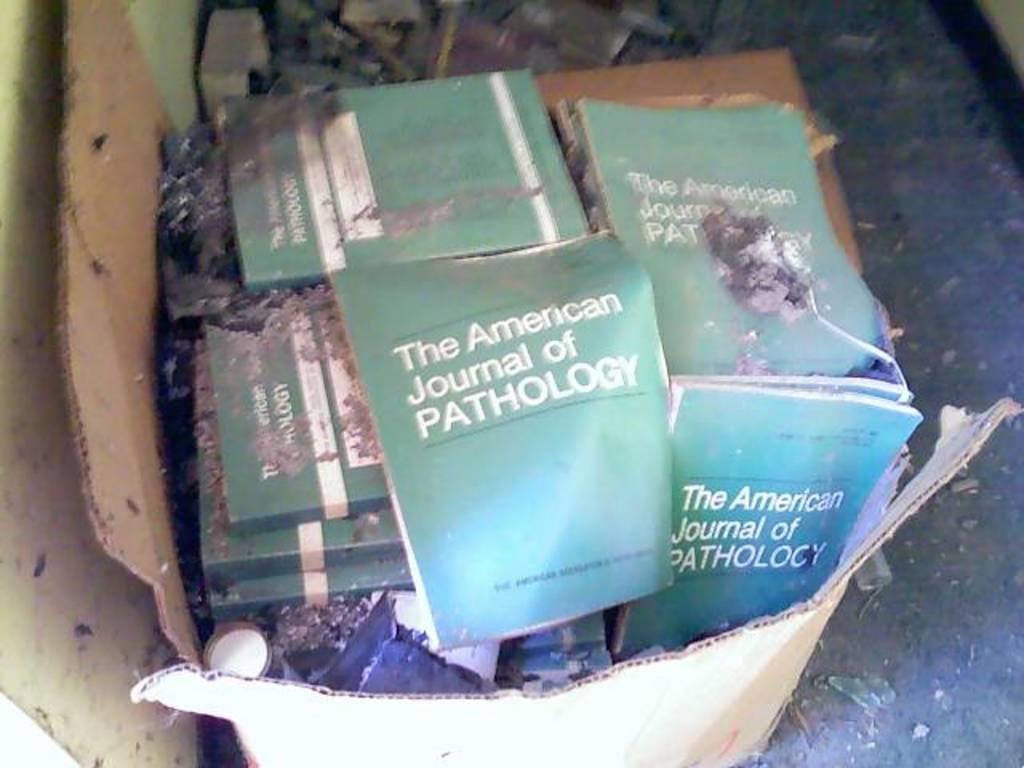Is the american journal of pathology a medical research book?
Your response must be concise. Unanswerable. What book is that?
Your answer should be very brief. The american journal of pathology. 